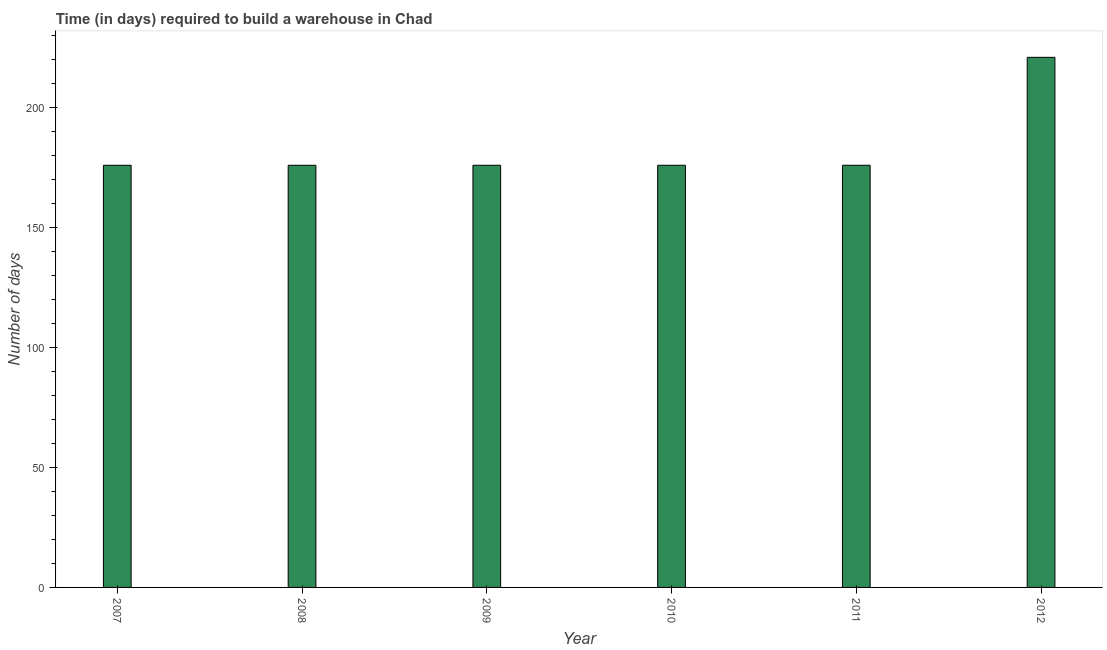Does the graph contain any zero values?
Provide a succinct answer. No. What is the title of the graph?
Your answer should be very brief. Time (in days) required to build a warehouse in Chad. What is the label or title of the Y-axis?
Make the answer very short. Number of days. What is the time required to build a warehouse in 2008?
Offer a terse response. 176. Across all years, what is the maximum time required to build a warehouse?
Offer a very short reply. 221. Across all years, what is the minimum time required to build a warehouse?
Provide a short and direct response. 176. In which year was the time required to build a warehouse maximum?
Offer a terse response. 2012. In which year was the time required to build a warehouse minimum?
Provide a short and direct response. 2007. What is the sum of the time required to build a warehouse?
Give a very brief answer. 1101. What is the average time required to build a warehouse per year?
Give a very brief answer. 183. What is the median time required to build a warehouse?
Offer a terse response. 176. In how many years, is the time required to build a warehouse greater than 190 days?
Offer a very short reply. 1. Do a majority of the years between 2010 and 2012 (inclusive) have time required to build a warehouse greater than 130 days?
Offer a very short reply. Yes. What is the ratio of the time required to build a warehouse in 2007 to that in 2008?
Offer a terse response. 1. Is the time required to build a warehouse in 2010 less than that in 2011?
Offer a very short reply. No. What is the difference between the highest and the second highest time required to build a warehouse?
Make the answer very short. 45. Are all the bars in the graph horizontal?
Keep it short and to the point. No. What is the difference between two consecutive major ticks on the Y-axis?
Make the answer very short. 50. What is the Number of days of 2007?
Keep it short and to the point. 176. What is the Number of days of 2008?
Provide a succinct answer. 176. What is the Number of days of 2009?
Give a very brief answer. 176. What is the Number of days in 2010?
Give a very brief answer. 176. What is the Number of days of 2011?
Provide a short and direct response. 176. What is the Number of days in 2012?
Provide a succinct answer. 221. What is the difference between the Number of days in 2007 and 2008?
Make the answer very short. 0. What is the difference between the Number of days in 2007 and 2010?
Make the answer very short. 0. What is the difference between the Number of days in 2007 and 2011?
Offer a terse response. 0. What is the difference between the Number of days in 2007 and 2012?
Ensure brevity in your answer.  -45. What is the difference between the Number of days in 2008 and 2009?
Your answer should be very brief. 0. What is the difference between the Number of days in 2008 and 2011?
Your answer should be very brief. 0. What is the difference between the Number of days in 2008 and 2012?
Your answer should be very brief. -45. What is the difference between the Number of days in 2009 and 2010?
Offer a very short reply. 0. What is the difference between the Number of days in 2009 and 2011?
Offer a terse response. 0. What is the difference between the Number of days in 2009 and 2012?
Your answer should be compact. -45. What is the difference between the Number of days in 2010 and 2012?
Your answer should be very brief. -45. What is the difference between the Number of days in 2011 and 2012?
Provide a short and direct response. -45. What is the ratio of the Number of days in 2007 to that in 2011?
Give a very brief answer. 1. What is the ratio of the Number of days in 2007 to that in 2012?
Make the answer very short. 0.8. What is the ratio of the Number of days in 2008 to that in 2009?
Make the answer very short. 1. What is the ratio of the Number of days in 2008 to that in 2010?
Keep it short and to the point. 1. What is the ratio of the Number of days in 2008 to that in 2011?
Keep it short and to the point. 1. What is the ratio of the Number of days in 2008 to that in 2012?
Make the answer very short. 0.8. What is the ratio of the Number of days in 2009 to that in 2012?
Provide a short and direct response. 0.8. What is the ratio of the Number of days in 2010 to that in 2012?
Provide a succinct answer. 0.8. What is the ratio of the Number of days in 2011 to that in 2012?
Your answer should be very brief. 0.8. 